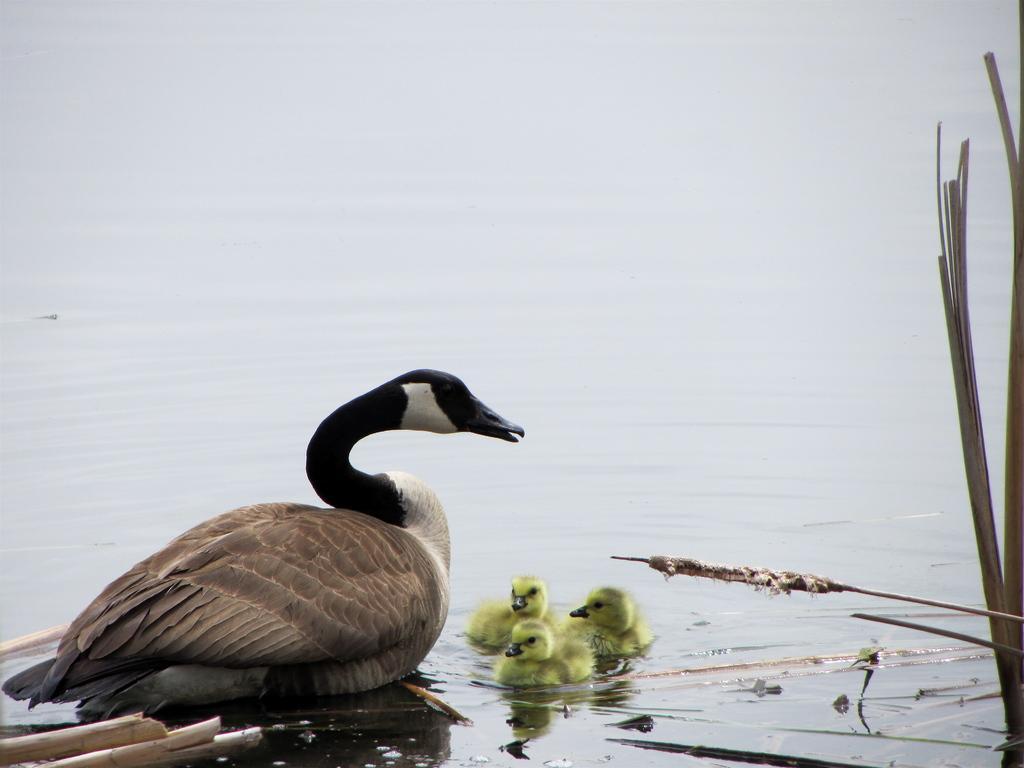In one or two sentences, can you explain what this image depicts? In this picture we can see a duck and ducklings on the water, and also we can see few plants. 